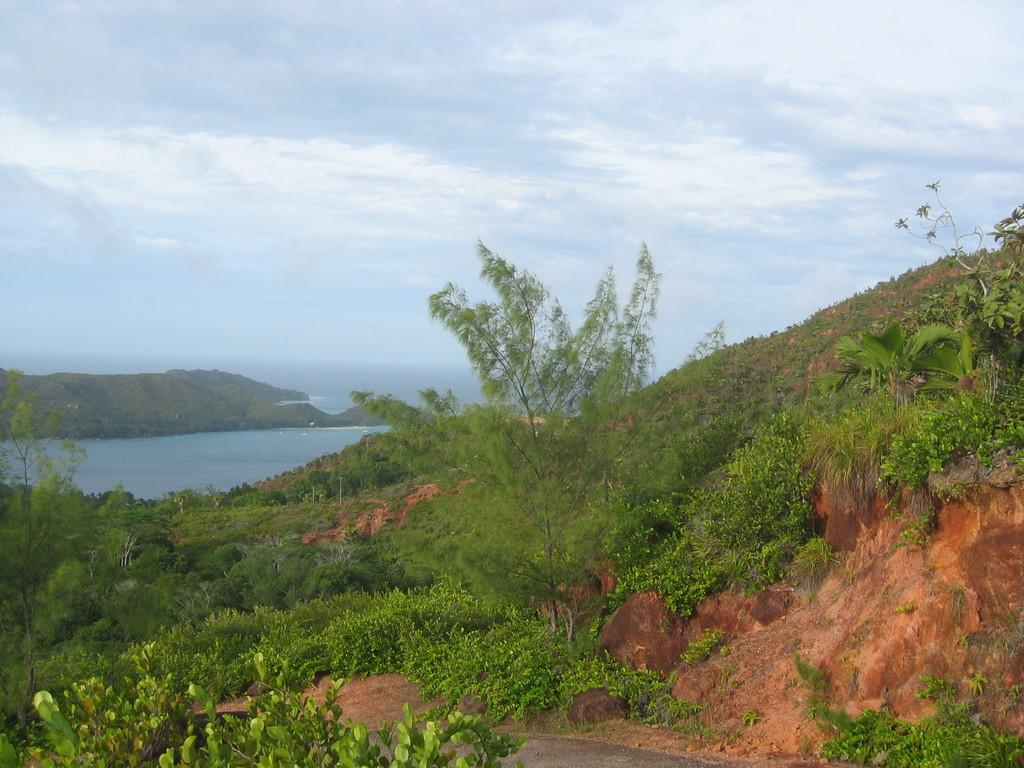Where is the picture taken from? The picture is taken over a hill. What can be seen in the foreground of the image? There are trees, plants, and rocks in the foreground of the image. What is the main feature in the center of the image? There is a water body and a hill in the center of the image. How would you describe the sky in the image? The sky is cloudy in the image. How many fangs can be seen on the rocks in the image? There are no fangs present in the image; the rocks are inanimate objects. What is the quietest way to cross the water body in the image? The image does not depict a method of crossing the water body, nor does it provide information about the noise level of any potential crossing methods. 